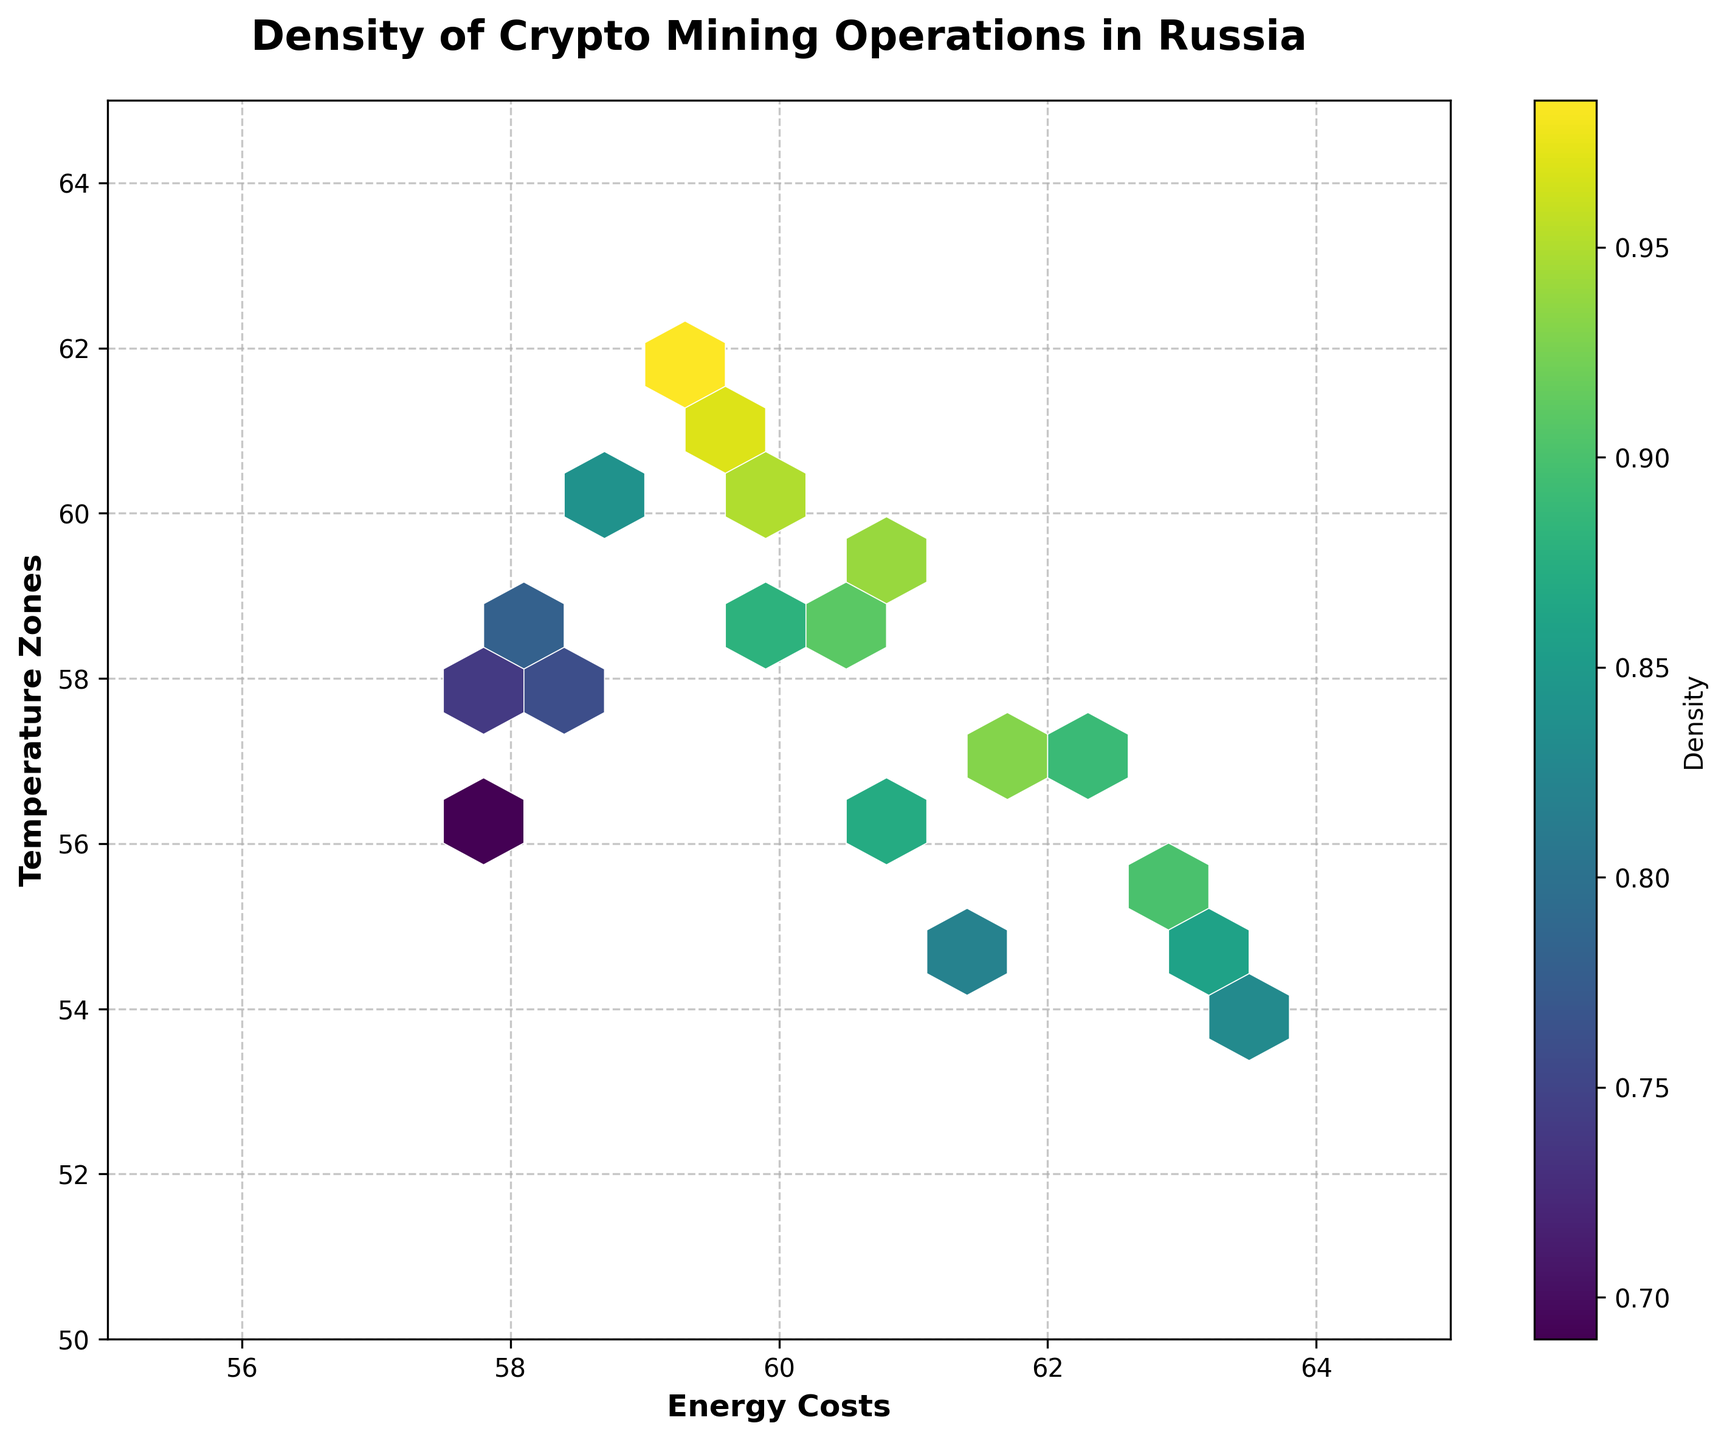What's the title of the figure? The title of the figure is located at the top and is in bold and large font.
Answer: Density of Crypto Mining Operations in Russia What do the x-axis and y-axis represent? The x-axis represents Energy Costs, and the y-axis represents Temperature Zones. These labels are visible at the bottom for the x-axis and on the side for the y-axis.
Answer: Energy Costs, Temperature Zones What is the range of the x-axis in this figure? The x-axis range is from 55 to 65, as indicated by the axis limits shown in the figure.
Answer: 55 to 65 What is the hexagon color for areas with high density? The color corresponding to high density areas is a lighter, more vibrant shade of yellow, as indicated by the color bar on the right.
Answer: Yellow How does energy cost relate to temperature zones according to this plot? The plot shows clusters indicating that higher density of mining operations occur when energy costs are between 59.0 and 61.0, overlapping with temperature zones between 58.0 and 61.0. Both axes show consistent clustering in this range.
Answer: Concentrated around 59.0-61.0 energy costs and 58.0-61.0 temperature zones What is the highest density value shown on the color bar? The highest density value can be identified by looking at the upper end of the color bar scale, where it indicates 1.0.
Answer: 1.0 Is there more than one high-density region, according to the hexbin plot? Observing the hexagon colors, there are multiple regions (more than one hexbin cluster) where high-density values (yellow color) appear, suggesting multiple high-density regions.
Answer: Yes What can be inferred about mining operations in relation to cost and temperature extremes? The density of mining operations is lower at the extremes of the energy cost and temperature zones, indicated by the darker (purple) regions towards the edges of the plot.
Answer: Lower density at extremes At what energy cost do the densest mining operations appear? The densest mining operations correspond to energy costs around 59.8 to 61.2, viewed as a concentration of yellow hexagons in this range.
Answer: Around 59.8 to 61.2 